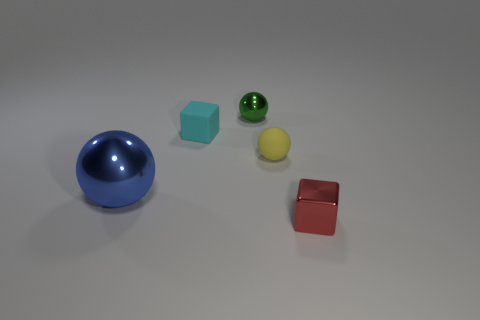Are there any other things that have the same size as the blue sphere?
Your answer should be compact. No. Are the small thing that is in front of the big shiny object and the large sphere made of the same material?
Keep it short and to the point. Yes. Do the tiny rubber object that is in front of the cyan cube and the block right of the yellow matte thing have the same color?
Give a very brief answer. No. How many tiny objects are in front of the cyan rubber object and to the left of the metal cube?
Offer a very short reply. 1. What material is the blue sphere?
Keep it short and to the point. Metal. What shape is the green object that is the same size as the red shiny block?
Offer a terse response. Sphere. Is the material of the tiny block that is behind the metallic block the same as the sphere to the left of the cyan thing?
Give a very brief answer. No. How many balls are there?
Keep it short and to the point. 3. How many large things are the same shape as the tiny yellow matte object?
Ensure brevity in your answer.  1. Do the red metallic thing and the small yellow matte object have the same shape?
Provide a short and direct response. No. 